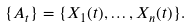<formula> <loc_0><loc_0><loc_500><loc_500>\{ A _ { t } \} = \{ X _ { 1 } ( t ) , \dots , X _ { n } ( t ) \} .</formula> 